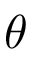<formula> <loc_0><loc_0><loc_500><loc_500>\theta</formula> 